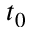<formula> <loc_0><loc_0><loc_500><loc_500>t _ { 0 }</formula> 